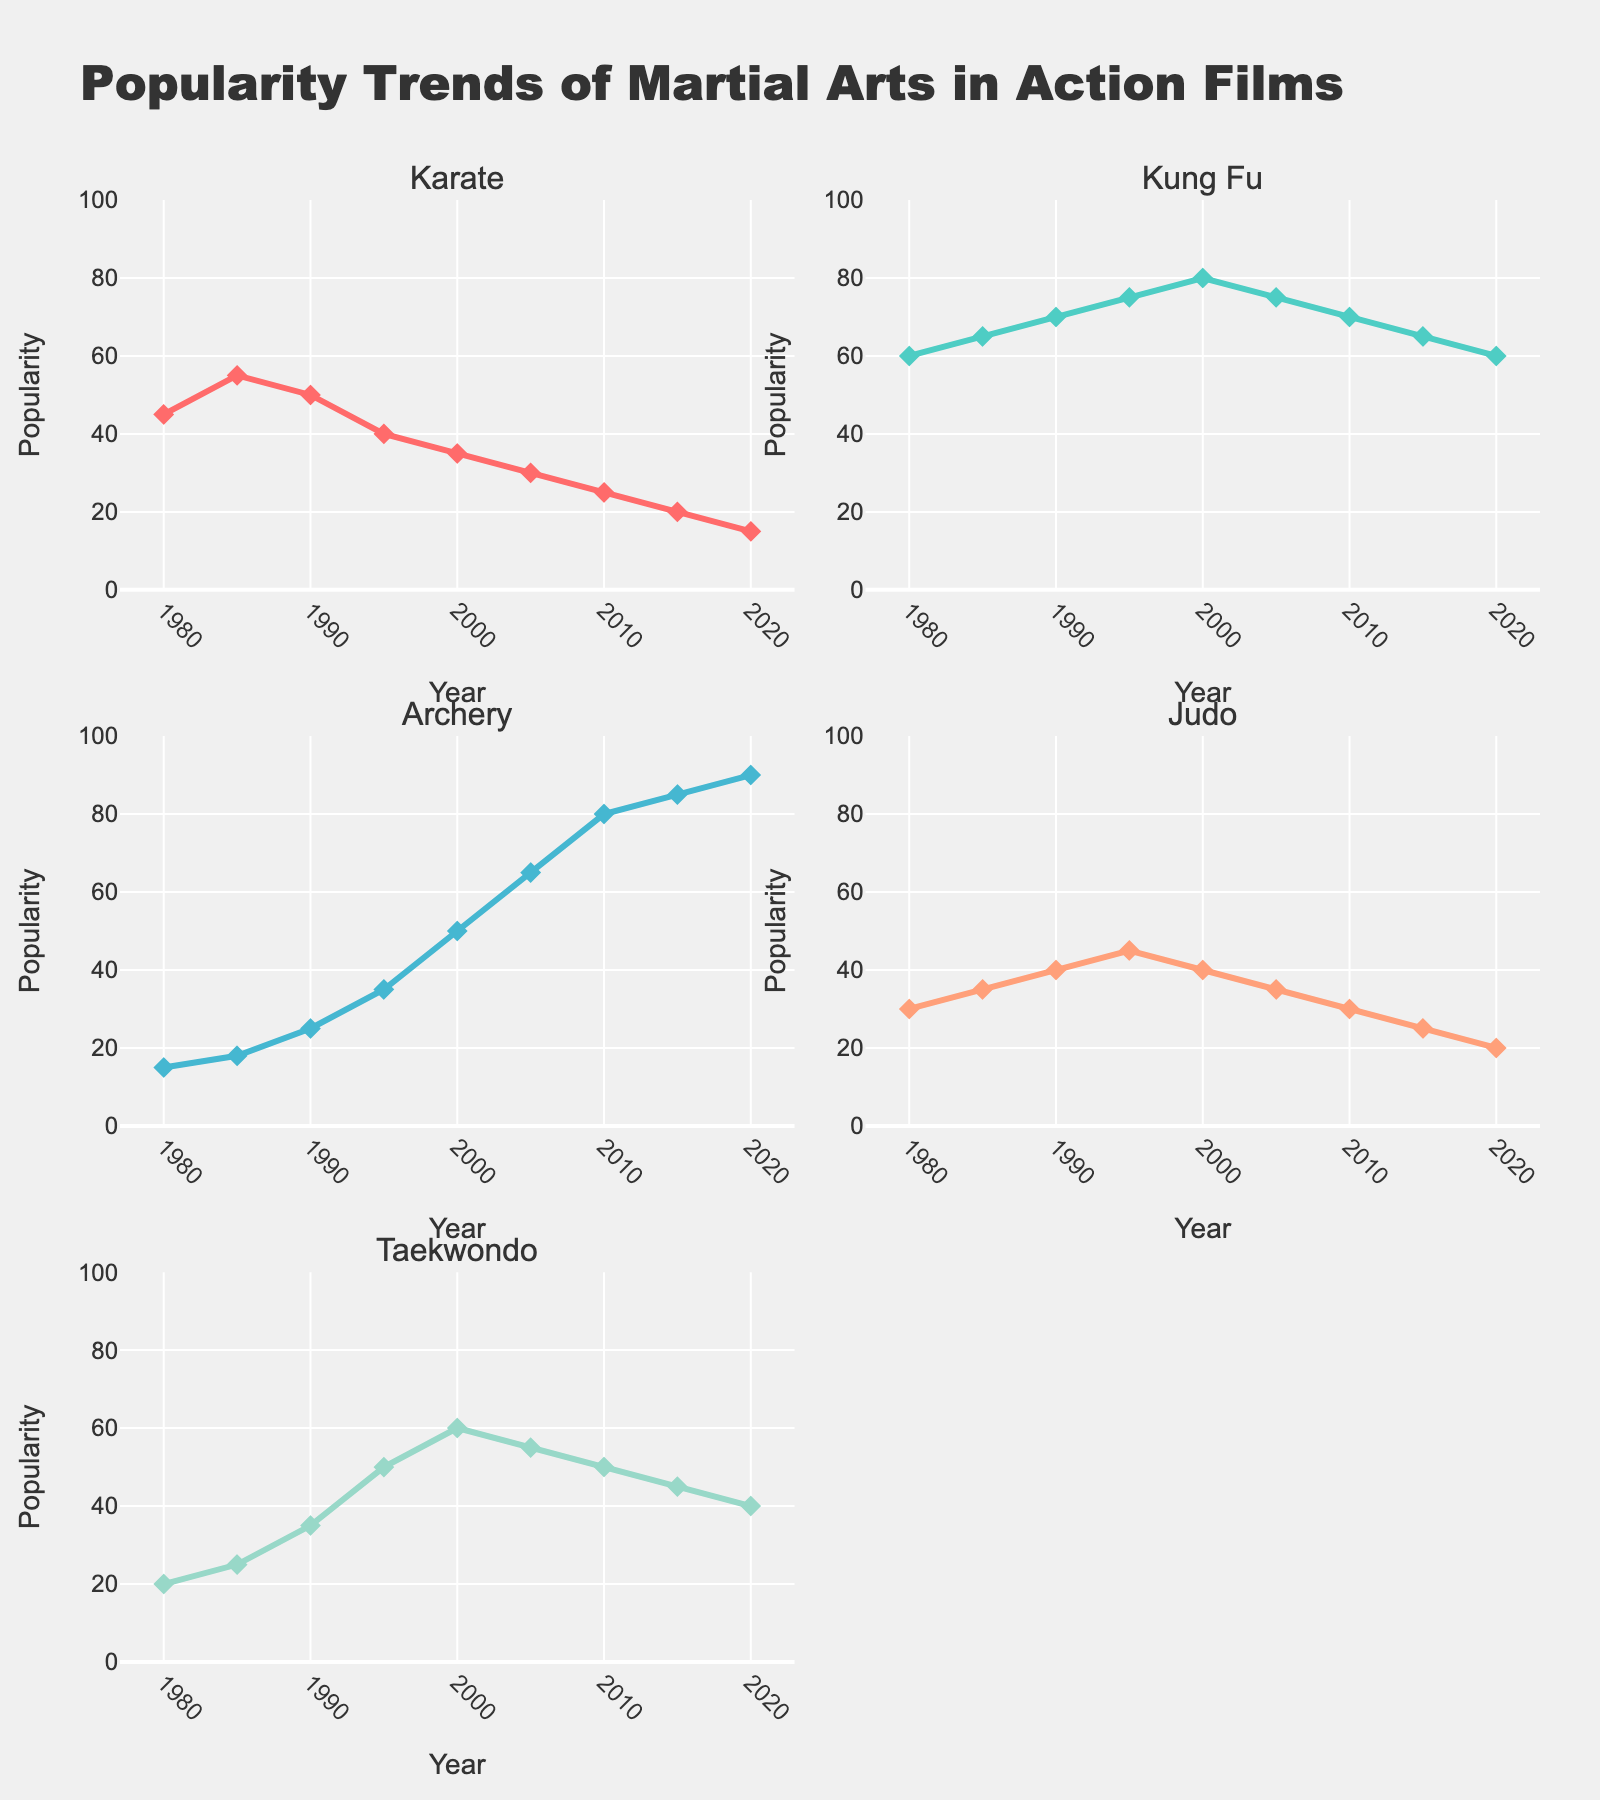What is the title of the plot? The title is displayed at the top of the figure, stating "Women's Participation in Professional Fields in Pakistan".
Answer: Women's Participation in Professional Fields in Pakistan Which field has the highest participation of women in Pakistan? The top subplot shows the "Top 5 Fields". The field with the highest bar is "Education" with a percentage of 42.7%.
Answer: Education Which field has the lowest participation of women in Pakistan? The bottom subplot shows the "Bottom 5 Fields". The field with the lowest bar is "Agriculture" with a percentage of 8.4%.
Answer: Agriculture How many fields have a participation percentage greater than 20%? Look at both subplots and count the fields with participation percentages above 20. They are Medicine, Education, Law, Business Administration, and Social Sciences, making it 5 fields in total.
Answer: 5 What is the combined percentage of women's participation in both Information Technology and Arts and Design? The percentages for Information Technology and Arts and Design are 12.8% and 16.7% respectively. Add them together to get the combined percentage: 12.8 + 16.7 = 29.5%.
Answer: 29.5% Which has higher participation: Law or Media and Journalism? In the "Top 5 Fields" subplot, Law shows a percentage of 18.9% and Media and Journalism shows 19.6%. So, Media and Journalism has higher participation.
Answer: Media and Journalism Compare the participation percentages of Engineering and Social Sciences. How much higher is Social Sciences? From the "Bottom 5 Fields" subplot, Engineering is at 15.2% and Social Sciences is in the "Top 5 Fields" subplot at 31.2%. The difference is 31.2 - 15.2 = 16.
Answer: 16% What is the range of percentages for the bottom 5 fields? The bottom 5 fields are Information Technology (12.8%), Arts and Design (16.7%), Engineering (15.2%), Agriculture (8.4%), and Law (18.9%). The range is the difference between the highest and the lowest percentages: 18.9 - 8.4 = 10.5.
Answer: 10.5 What field lies in the middle when the fields are sorted by participation percentage? Sorting the fields by percentage would have Education, Social Sciences, Medicine, Business Administration, Media and Journalism, Law, Arts and Design, Engineering, Information Technology, and Agriculture. Law is the middle field with a percentage of 18.9%.
Answer: Law 